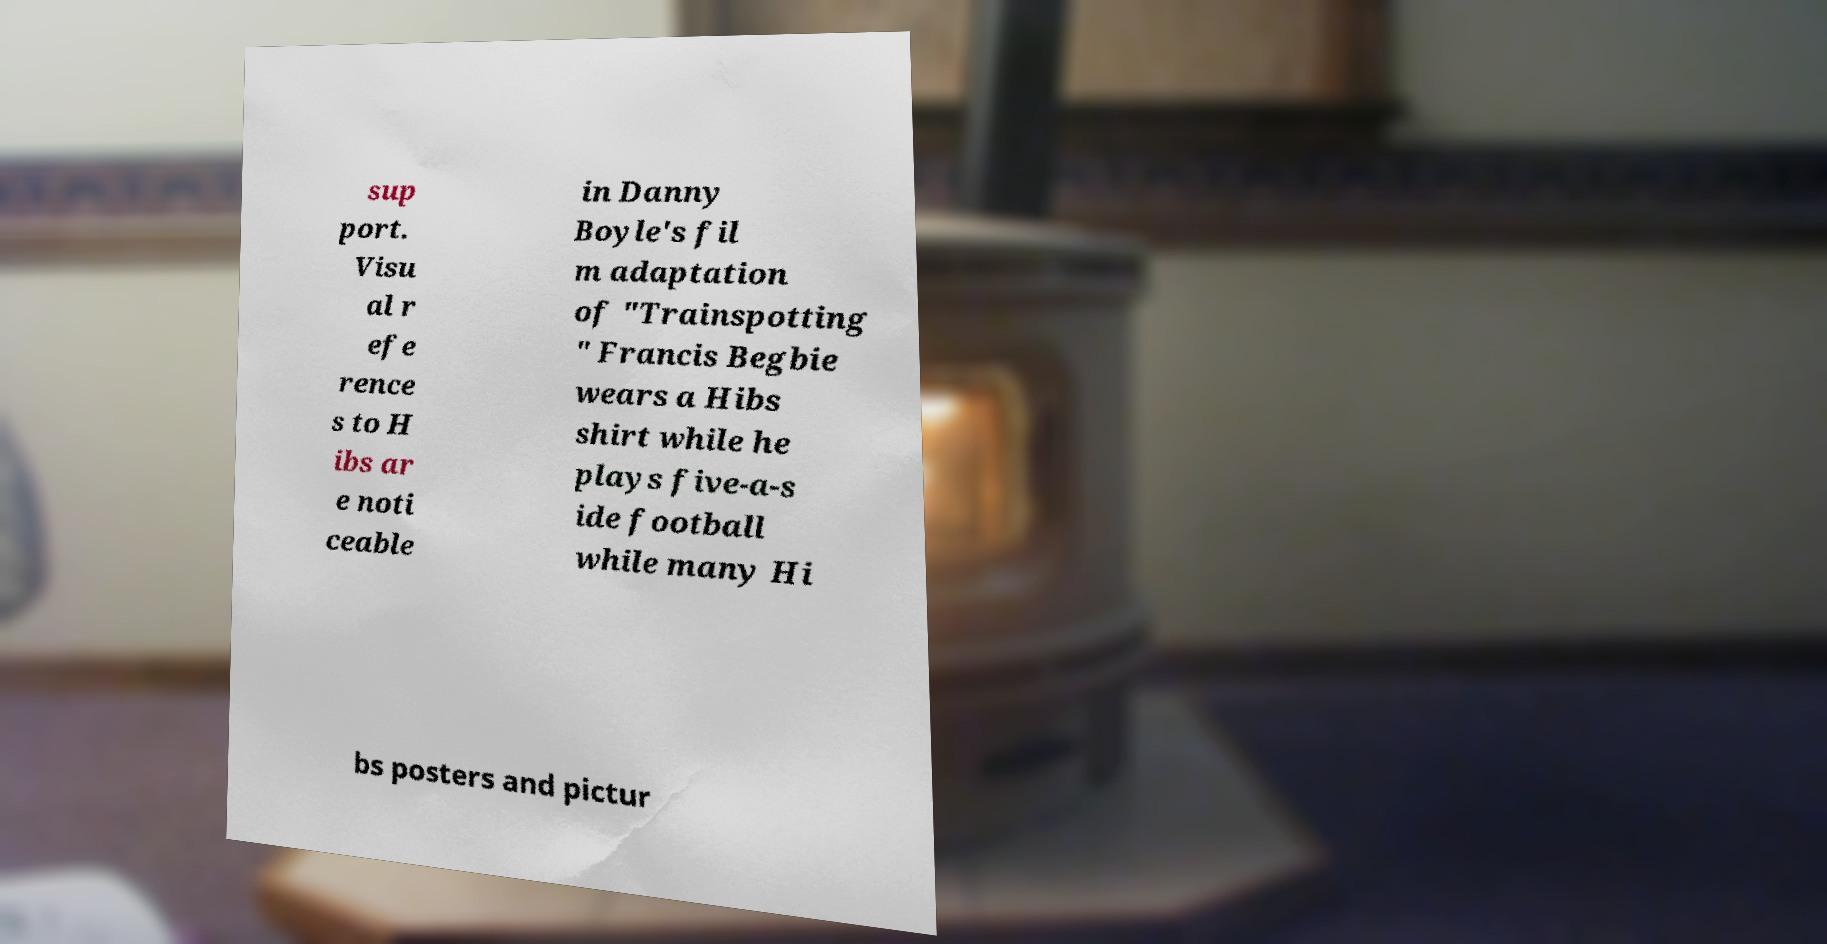What messages or text are displayed in this image? I need them in a readable, typed format. sup port. Visu al r efe rence s to H ibs ar e noti ceable in Danny Boyle's fil m adaptation of "Trainspotting " Francis Begbie wears a Hibs shirt while he plays five-a-s ide football while many Hi bs posters and pictur 